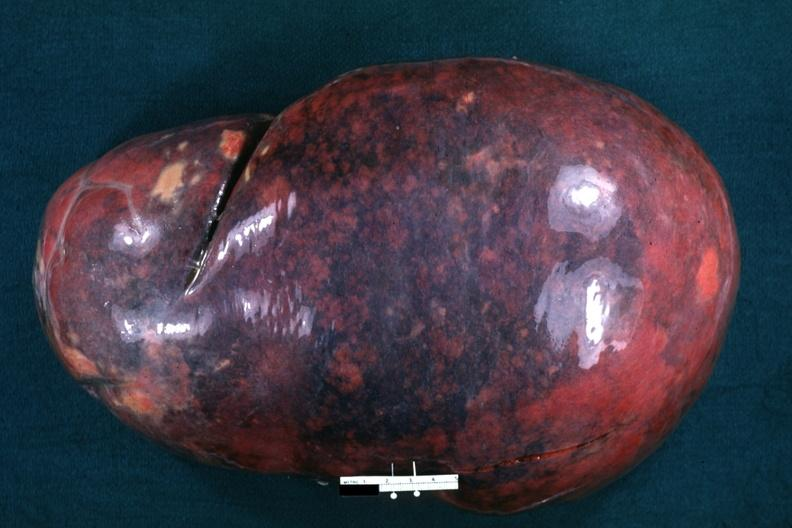where is this part in?
Answer the question using a single word or phrase. Spleen 